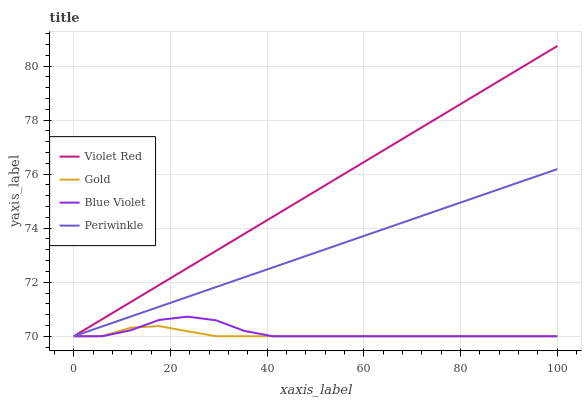Does Gold have the minimum area under the curve?
Answer yes or no. Yes. Does Violet Red have the maximum area under the curve?
Answer yes or no. Yes. Does Periwinkle have the minimum area under the curve?
Answer yes or no. No. Does Periwinkle have the maximum area under the curve?
Answer yes or no. No. Is Violet Red the smoothest?
Answer yes or no. Yes. Is Blue Violet the roughest?
Answer yes or no. Yes. Is Periwinkle the smoothest?
Answer yes or no. No. Is Periwinkle the roughest?
Answer yes or no. No. Does Violet Red have the lowest value?
Answer yes or no. Yes. Does Violet Red have the highest value?
Answer yes or no. Yes. Does Periwinkle have the highest value?
Answer yes or no. No. Does Periwinkle intersect Blue Violet?
Answer yes or no. Yes. Is Periwinkle less than Blue Violet?
Answer yes or no. No. Is Periwinkle greater than Blue Violet?
Answer yes or no. No. 